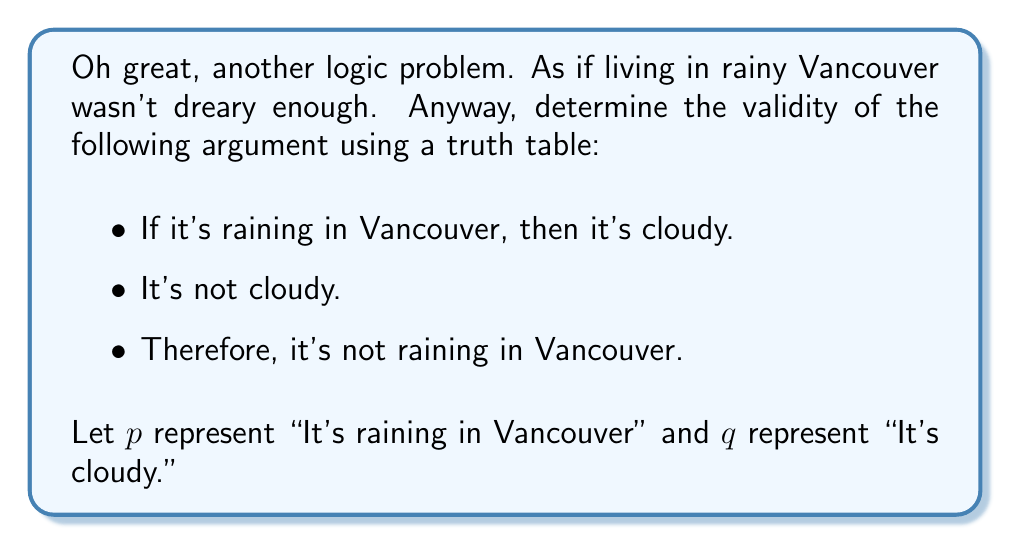Can you solve this math problem? Alright, let's break this down for all you non-Vancouverites who think we actually see the sun sometimes:

1) First, we need to translate the argument into symbolic logic:
   Premise 1: $p \rightarrow q$
   Premise 2: $\neg q$
   Conclusion: $\neg p$

2) Now, let's create a truth table with columns for $p$, $q$, $p \rightarrow q$, $\neg q$, and $\neg p$:

   $$
   \begin{array}{|c|c|c|c|c|}
   \hline
   p & q & p \rightarrow q & \neg q & \neg p \\
   \hline
   T & T & T & F & F \\
   T & F & F & T & F \\
   F & T & T & F & T \\
   F & F & T & T & T \\
   \hline
   \end{array}
   $$

3) Let's evaluate each row:
   - When $p$ is true and $q$ is true, $p \rightarrow q$ is true, $\neg q$ is false, and $\neg p$ is false.
   - When $p$ is true and $q$ is false, $p \rightarrow q$ is false, $\neg q$ is true, and $\neg p$ is false.
   - When $p$ is false and $q$ is true, $p \rightarrow q$ is true, $\neg q$ is false, and $\neg p$ is true.
   - When $p$ is false and $q$ is false, $p \rightarrow q$ is true, $\neg q$ is true, and $\neg p$ is true.

4) An argument is valid if, in every row where all premises are true, the conclusion is also true.

5) The premises are both true only in the last row (where $p$ is false and $q$ is false). In this row, the conclusion $\neg p$ is also true.

Therefore, despite my sarcastic disposition towards Vancouver's weather, this argument is indeed valid. Who would've thought logic could actually be useful in this rain-soaked city?
Answer: The argument is valid. 